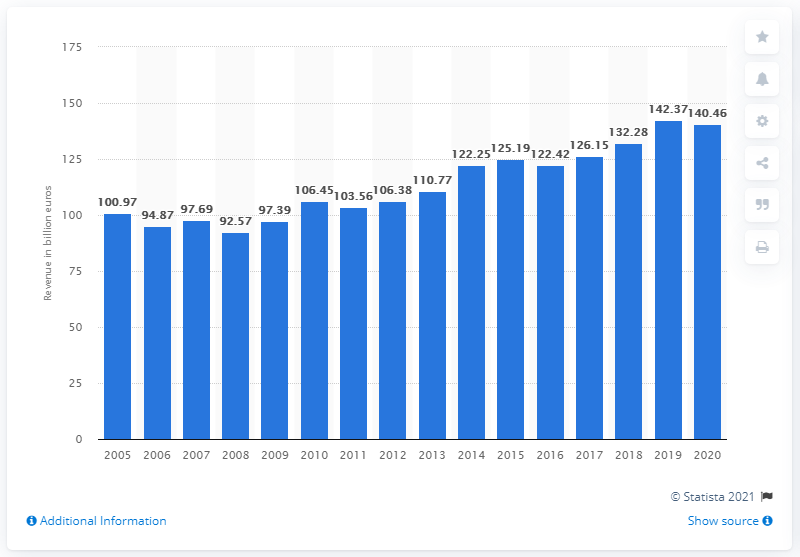Draw attention to some important aspects in this diagram. In 2020, the total revenue of Allianz Group was 140.46 billion euros. 